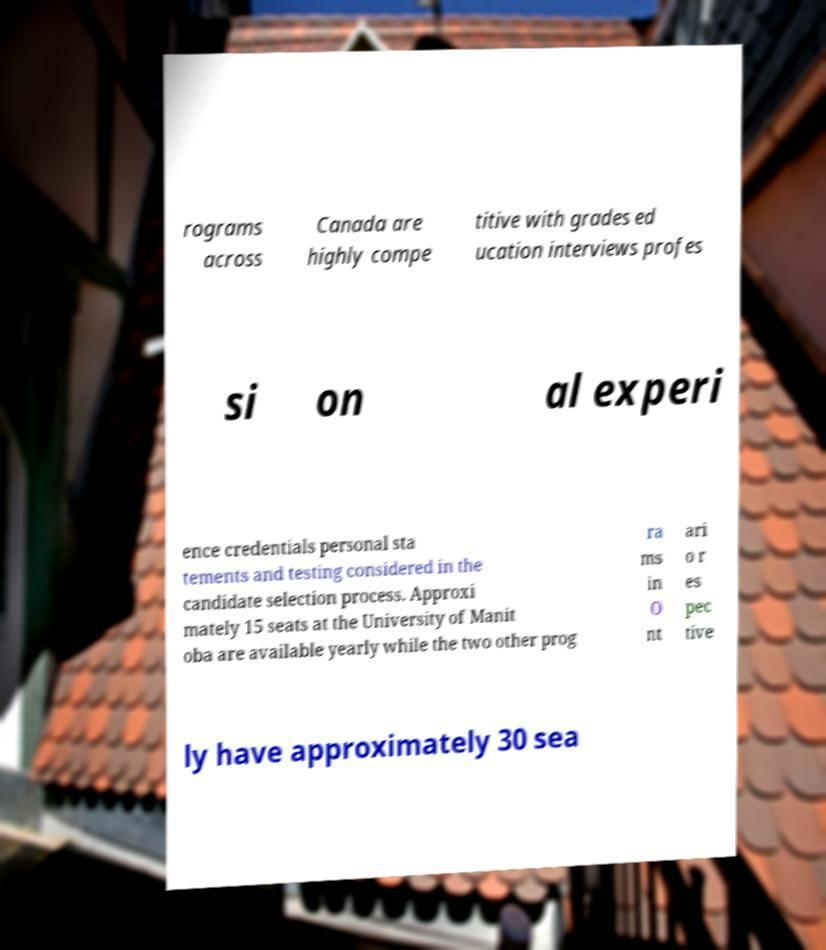Please identify and transcribe the text found in this image. rograms across Canada are highly compe titive with grades ed ucation interviews profes si on al experi ence credentials personal sta tements and testing considered in the candidate selection process. Approxi mately 15 seats at the University of Manit oba are available yearly while the two other prog ra ms in O nt ari o r es pec tive ly have approximately 30 sea 